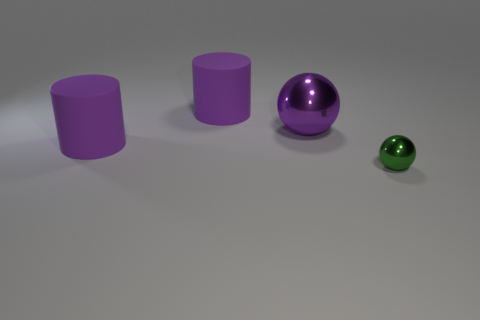Subtract 2 cylinders. How many cylinders are left? 0 Add 2 large brown rubber things. How many objects exist? 6 Subtract all blue cubes. How many green spheres are left? 1 Subtract all blue rubber things. Subtract all small spheres. How many objects are left? 3 Add 2 metal balls. How many metal balls are left? 4 Add 4 tiny green spheres. How many tiny green spheres exist? 5 Subtract 1 purple balls. How many objects are left? 3 Subtract all green cylinders. Subtract all gray cubes. How many cylinders are left? 2 